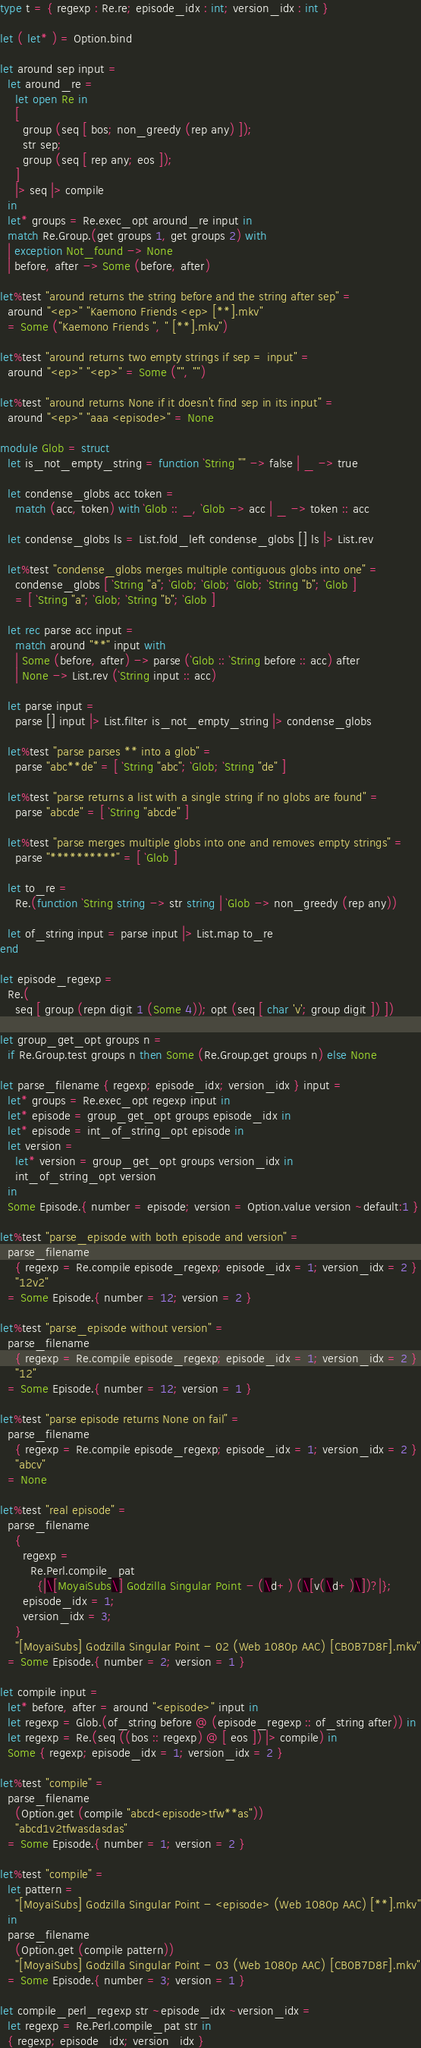Convert code to text. <code><loc_0><loc_0><loc_500><loc_500><_OCaml_>type t = { regexp : Re.re; episode_idx : int; version_idx : int }

let ( let* ) = Option.bind

let around sep input =
  let around_re =
    let open Re in
    [
      group (seq [ bos; non_greedy (rep any) ]);
      str sep;
      group (seq [ rep any; eos ]);
    ]
    |> seq |> compile
  in
  let* groups = Re.exec_opt around_re input in
  match Re.Group.(get groups 1, get groups 2) with
  | exception Not_found -> None
  | before, after -> Some (before, after)

let%test "around returns the string before and the string after sep" =
  around "<ep>" "Kaemono Friends <ep> [**].mkv"
  = Some ("Kaemono Friends ", " [**].mkv")

let%test "around returns two empty strings if sep = input" =
  around "<ep>" "<ep>" = Some ("", "")

let%test "around returns None if it doesn't find sep in its input" =
  around "<ep>" "aaa <episode>" = None

module Glob = struct
  let is_not_empty_string = function `String "" -> false | _ -> true

  let condense_globs acc token =
    match (acc, token) with `Glob :: _, `Glob -> acc | _ -> token :: acc

  let condense_globs ls = List.fold_left condense_globs [] ls |> List.rev

  let%test "condense_globs merges multiple contiguous globs into one" =
    condense_globs [ `String "a"; `Glob; `Glob; `Glob; `String "b"; `Glob ]
    = [ `String "a"; `Glob; `String "b"; `Glob ]

  let rec parse acc input =
    match around "**" input with
    | Some (before, after) -> parse (`Glob :: `String before :: acc) after
    | None -> List.rev (`String input :: acc)

  let parse input =
    parse [] input |> List.filter is_not_empty_string |> condense_globs

  let%test "parse parses ** into a glob" =
    parse "abc**de" = [ `String "abc"; `Glob; `String "de" ]

  let%test "parse returns a list with a single string if no globs are found" =
    parse "abcde" = [ `String "abcde" ]

  let%test "parse merges multiple globs into one and removes empty strings" =
    parse "**********" = [ `Glob ]

  let to_re =
    Re.(function `String string -> str string | `Glob -> non_greedy (rep any))

  let of_string input = parse input |> List.map to_re
end

let episode_regexp =
  Re.(
    seq [ group (repn digit 1 (Some 4)); opt (seq [ char 'v'; group digit ]) ])

let group_get_opt groups n =
  if Re.Group.test groups n then Some (Re.Group.get groups n) else None

let parse_filename { regexp; episode_idx; version_idx } input =
  let* groups = Re.exec_opt regexp input in
  let* episode = group_get_opt groups episode_idx in
  let* episode = int_of_string_opt episode in
  let version =
    let* version = group_get_opt groups version_idx in
    int_of_string_opt version
  in
  Some Episode.{ number = episode; version = Option.value version ~default:1 }

let%test "parse_episode with both episode and version" =
  parse_filename
    { regexp = Re.compile episode_regexp; episode_idx = 1; version_idx = 2 }
    "12v2"
  = Some Episode.{ number = 12; version = 2 }

let%test "parse_episode without version" =
  parse_filename
    { regexp = Re.compile episode_regexp; episode_idx = 1; version_idx = 2 }
    "12"
  = Some Episode.{ number = 12; version = 1 }

let%test "parse episode returns None on fail" =
  parse_filename
    { regexp = Re.compile episode_regexp; episode_idx = 1; version_idx = 2 }
    "abcv"
  = None

let%test "real episode" =
  parse_filename
    {
      regexp =
        Re.Perl.compile_pat
          {|\[MoyaiSubs\] Godzilla Singular Point - (\d+) (\[v(\d+)\])?|};
      episode_idx = 1;
      version_idx = 3;
    }
    "[MoyaiSubs] Godzilla Singular Point - 02 (Web 1080p AAC) [CB0B7D8F].mkv"
  = Some Episode.{ number = 2; version = 1 }

let compile input =
  let* before, after = around "<episode>" input in
  let regexp = Glob.(of_string before @ (episode_regexp :: of_string after)) in
  let regexp = Re.(seq ((bos :: regexp) @ [ eos ]) |> compile) in
  Some { regexp; episode_idx = 1; version_idx = 2 }

let%test "compile" =
  parse_filename
    (Option.get (compile "abcd<episode>tfw**as"))
    "abcd1v2tfwasdasdas"
  = Some Episode.{ number = 1; version = 2 }

let%test "compile" =
  let pattern =
    "[MoyaiSubs] Godzilla Singular Point - <episode> (Web 1080p AAC) [**].mkv"
  in
  parse_filename
    (Option.get (compile pattern))
    "[MoyaiSubs] Godzilla Singular Point - 03 (Web 1080p AAC) [CB0B7D8F].mkv"
  = Some Episode.{ number = 3; version = 1 }

let compile_perl_regexp str ~episode_idx ~version_idx =
  let regexp = Re.Perl.compile_pat str in
  { regexp; episode_idx; version_idx }
</code> 